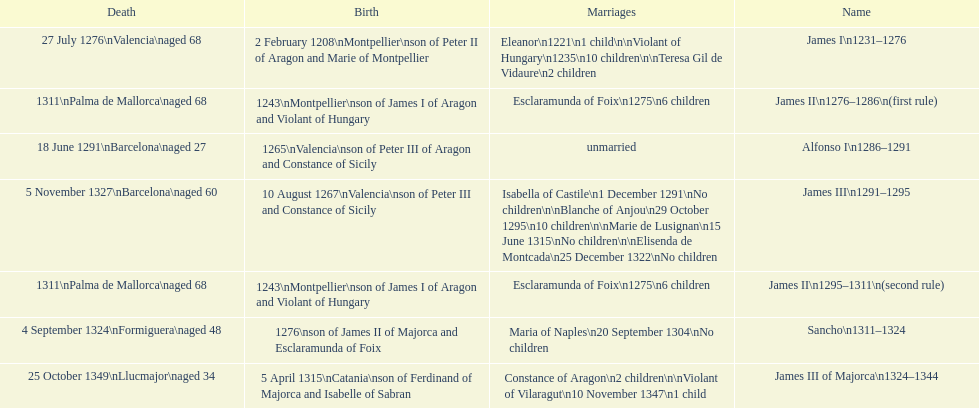Which two monarchs had no children? Alfonso I, Sancho. 